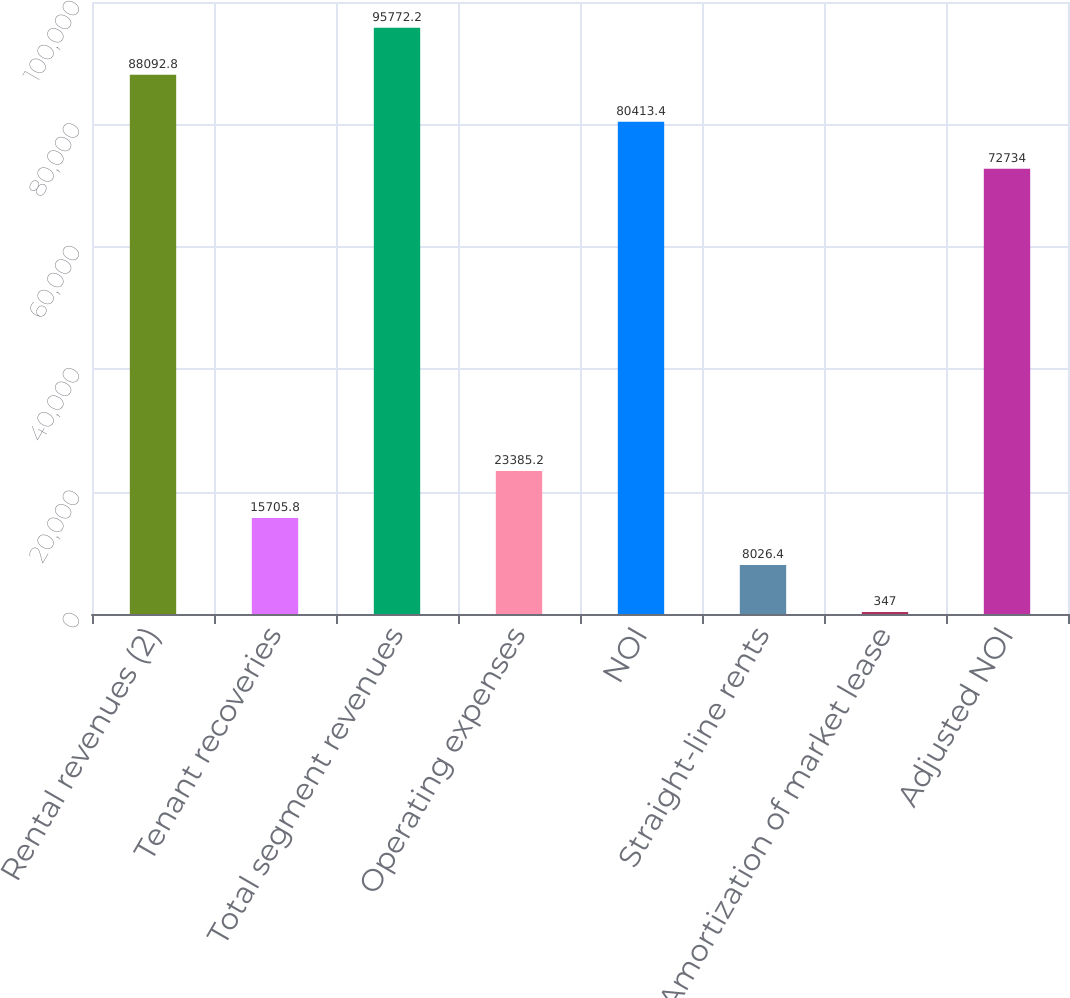<chart> <loc_0><loc_0><loc_500><loc_500><bar_chart><fcel>Rental revenues (2)<fcel>Tenant recoveries<fcel>Total segment revenues<fcel>Operating expenses<fcel>NOI<fcel>Straight-line rents<fcel>Amortization of market lease<fcel>Adjusted NOI<nl><fcel>88092.8<fcel>15705.8<fcel>95772.2<fcel>23385.2<fcel>80413.4<fcel>8026.4<fcel>347<fcel>72734<nl></chart> 